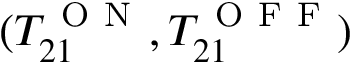Convert formula to latex. <formula><loc_0><loc_0><loc_500><loc_500>( T _ { 2 1 } ^ { O N } , T _ { 2 1 } ^ { O F F } )</formula> 